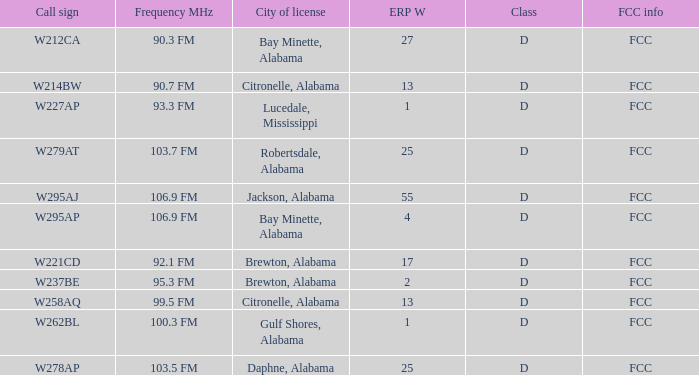Name the call sign for ERP W of 4 W295AP. 